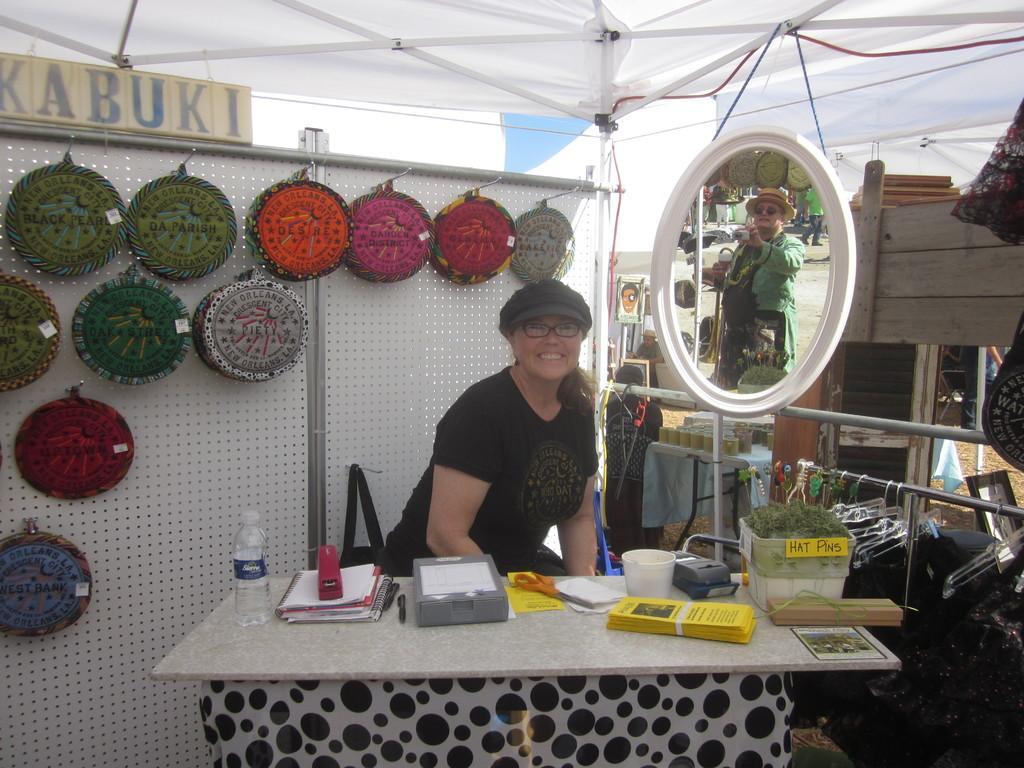Could you give a brief overview of what you see in this image? Here we can see a woman. She has spectacles and she is smiling. This is table. On the table there papers, pen, bottle, box, and a device. This is mirror. In the mirror we can see the reflection of a person. In the background we can see a board, sky, and objects. 